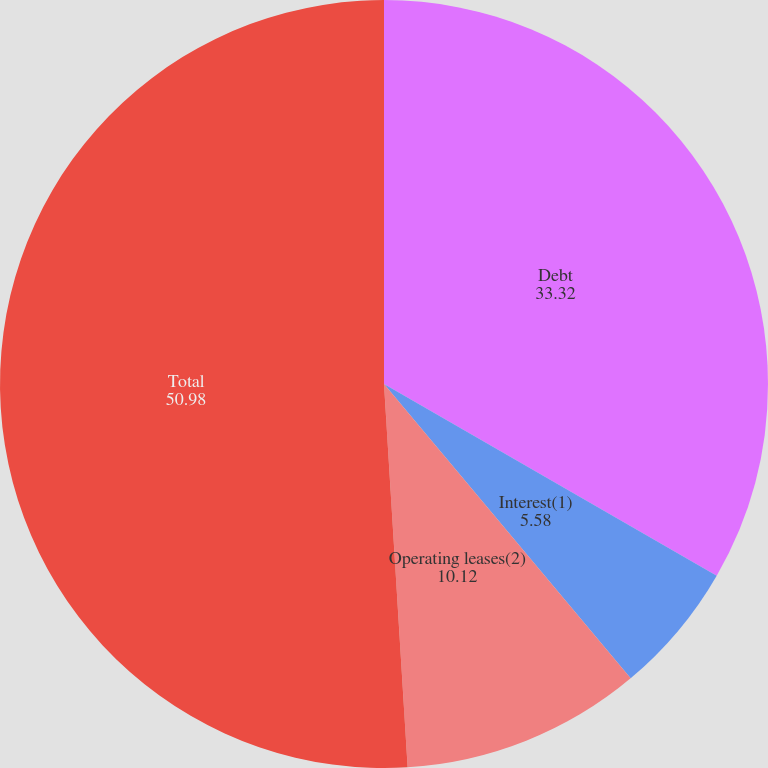Convert chart. <chart><loc_0><loc_0><loc_500><loc_500><pie_chart><fcel>Debt<fcel>Interest(1)<fcel>Operating leases(2)<fcel>Total<nl><fcel>33.32%<fcel>5.58%<fcel>10.12%<fcel>50.98%<nl></chart> 